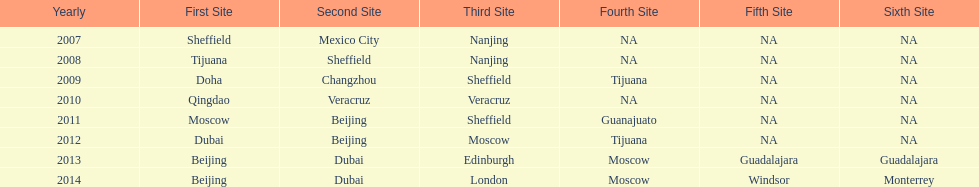Which year featured a greater number of venues, 2007 or 2012? 2012. 